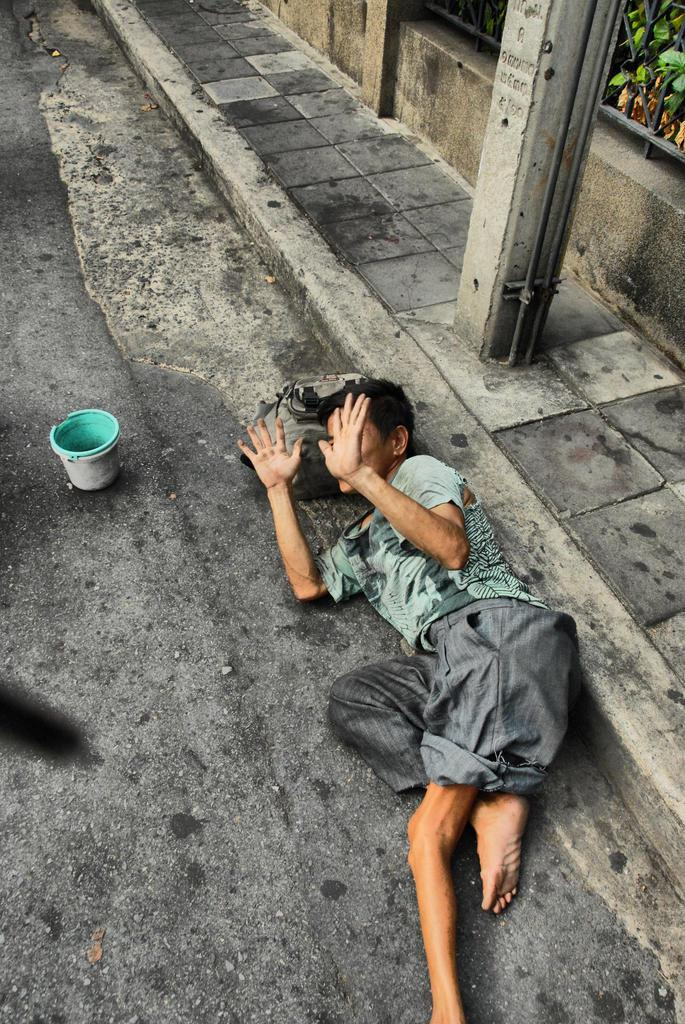What is the boy doing in the image? The boy is laying on the road in the image. What is in front of the boy? There is an object in front of the boy. What can be seen on the footpath? There is a pole on the footpath. What is behind the pole? There is a wall behind the pole. What type of quartz can be seen in the boy's hand in the image? There is no quartz present in the image, and the boy's hands are not visible. What type of shade is provided by the wall in the image? The image does not show any shade being provided by the wall; it only shows the wall's presence. 